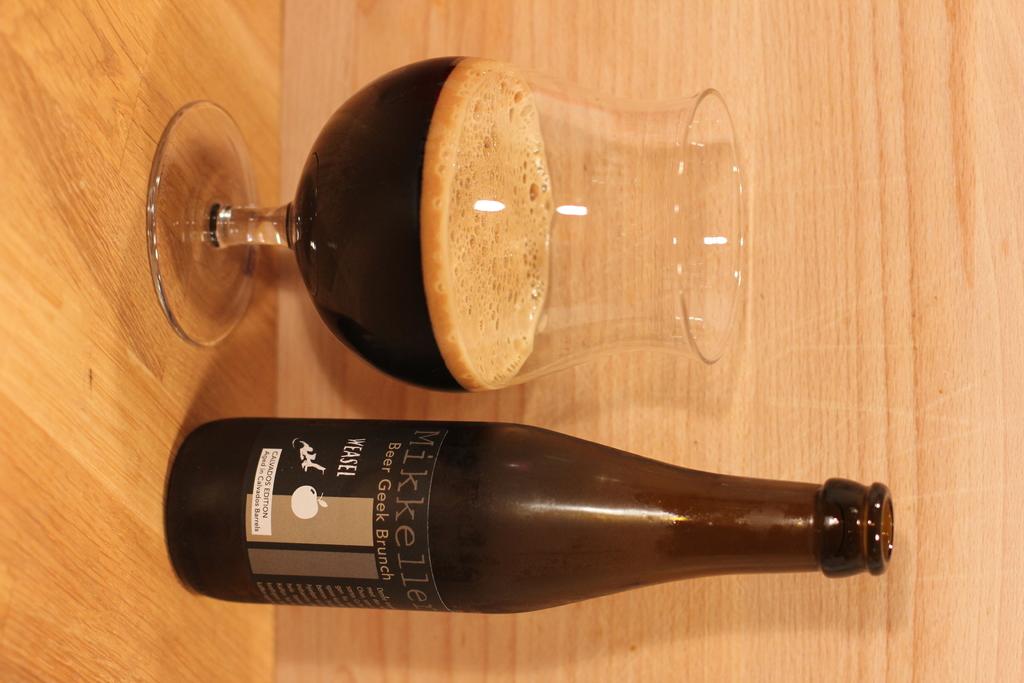What name is at the top of the label on the bottle?
Your answer should be compact. Mikkeller. What animal is named on the logo?
Offer a terse response. Weasel. 